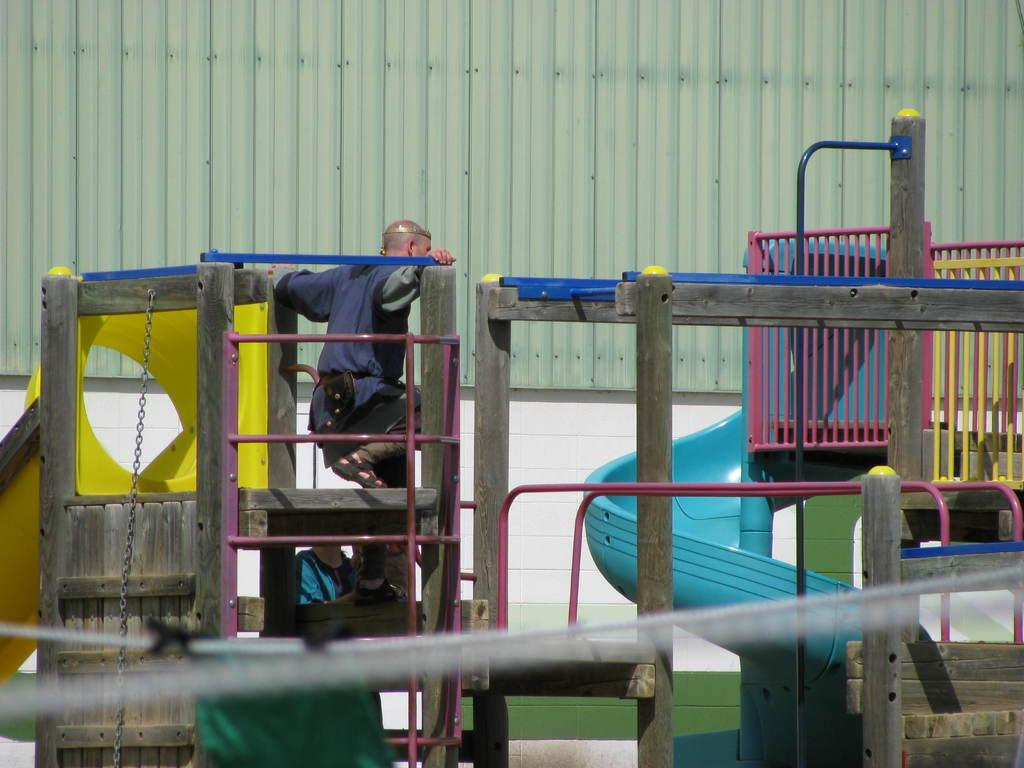What type of play equipment is visible in the image? There is Kinder play equipment in the image. How many people are in the image? There are two persons in the image. What can be seen in the background of the image? There is a wall in the background of the image. How many books are being read by the rabbits in the image? There are no rabbits or books present in the image. 